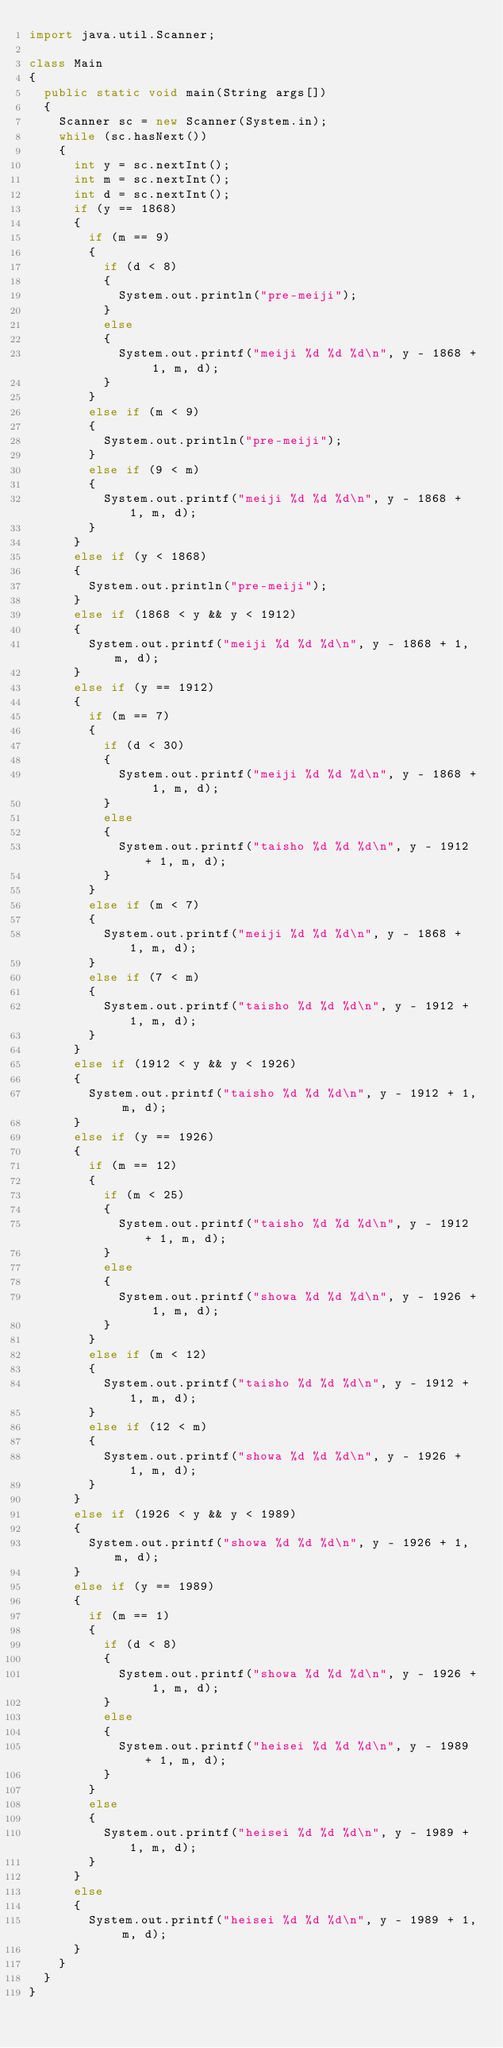Convert code to text. <code><loc_0><loc_0><loc_500><loc_500><_Java_>import java.util.Scanner;

class Main
{
	public static void main(String args[])
	{
		Scanner sc = new Scanner(System.in);
		while (sc.hasNext())
		{
			int y = sc.nextInt();
			int m = sc.nextInt();
			int d = sc.nextInt();
			if (y == 1868)
			{
				if (m == 9)
				{
					if (d < 8)
					{
						System.out.println("pre-meiji");
					}
					else
					{
						System.out.printf("meiji %d %d %d\n", y - 1868 + 1, m, d);
					}
				}
				else if (m < 9)
				{
					System.out.println("pre-meiji");
				}
				else if (9 < m)
				{
					System.out.printf("meiji %d %d %d\n", y - 1868 + 1, m, d);
				}
			}
			else if (y < 1868)
			{
				System.out.println("pre-meiji");
			}
			else if (1868 < y && y < 1912)
			{
				System.out.printf("meiji %d %d %d\n", y - 1868 + 1, m, d);
			}
			else if (y == 1912)
			{
				if (m == 7)
				{
					if (d < 30)
					{
						System.out.printf("meiji %d %d %d\n", y - 1868 + 1, m, d);
					}
					else
					{
						System.out.printf("taisho %d %d %d\n", y - 1912 + 1, m, d);
					}
				}
				else if (m < 7)
				{
					System.out.printf("meiji %d %d %d\n", y - 1868 + 1, m, d);
				}
				else if (7 < m)
				{
					System.out.printf("taisho %d %d %d\n", y - 1912 + 1, m, d);
				}
			}
			else if (1912 < y && y < 1926)
			{
				System.out.printf("taisho %d %d %d\n", y - 1912 + 1, m, d);
			}
			else if (y == 1926)
			{
				if (m == 12)
				{
					if (m < 25)
					{
						System.out.printf("taisho %d %d %d\n", y - 1912 + 1, m, d);
					}
					else
					{
						System.out.printf("showa %d %d %d\n", y - 1926 + 1, m, d);
					}
				}
				else if (m < 12)
				{
					System.out.printf("taisho %d %d %d\n", y - 1912 + 1, m, d);
				}
				else if (12 < m)
				{
					System.out.printf("showa %d %d %d\n", y - 1926 + 1, m, d);
				}
			}
			else if (1926 < y && y < 1989)
			{
				System.out.printf("showa %d %d %d\n", y - 1926 + 1, m, d);
			}
			else if (y == 1989)				
			{
				if (m == 1)
				{
					if (d < 8)
					{
						System.out.printf("showa %d %d %d\n", y - 1926 + 1, m, d);
					}
					else
					{
						System.out.printf("heisei %d %d %d\n", y - 1989 + 1, m, d);
					}
				}
				else
				{
					System.out.printf("heisei %d %d %d\n", y - 1989 + 1, m, d);
				}
			}
			else
			{
				System.out.printf("heisei %d %d %d\n", y - 1989 + 1, m, d);
			}
		}
	}
}</code> 